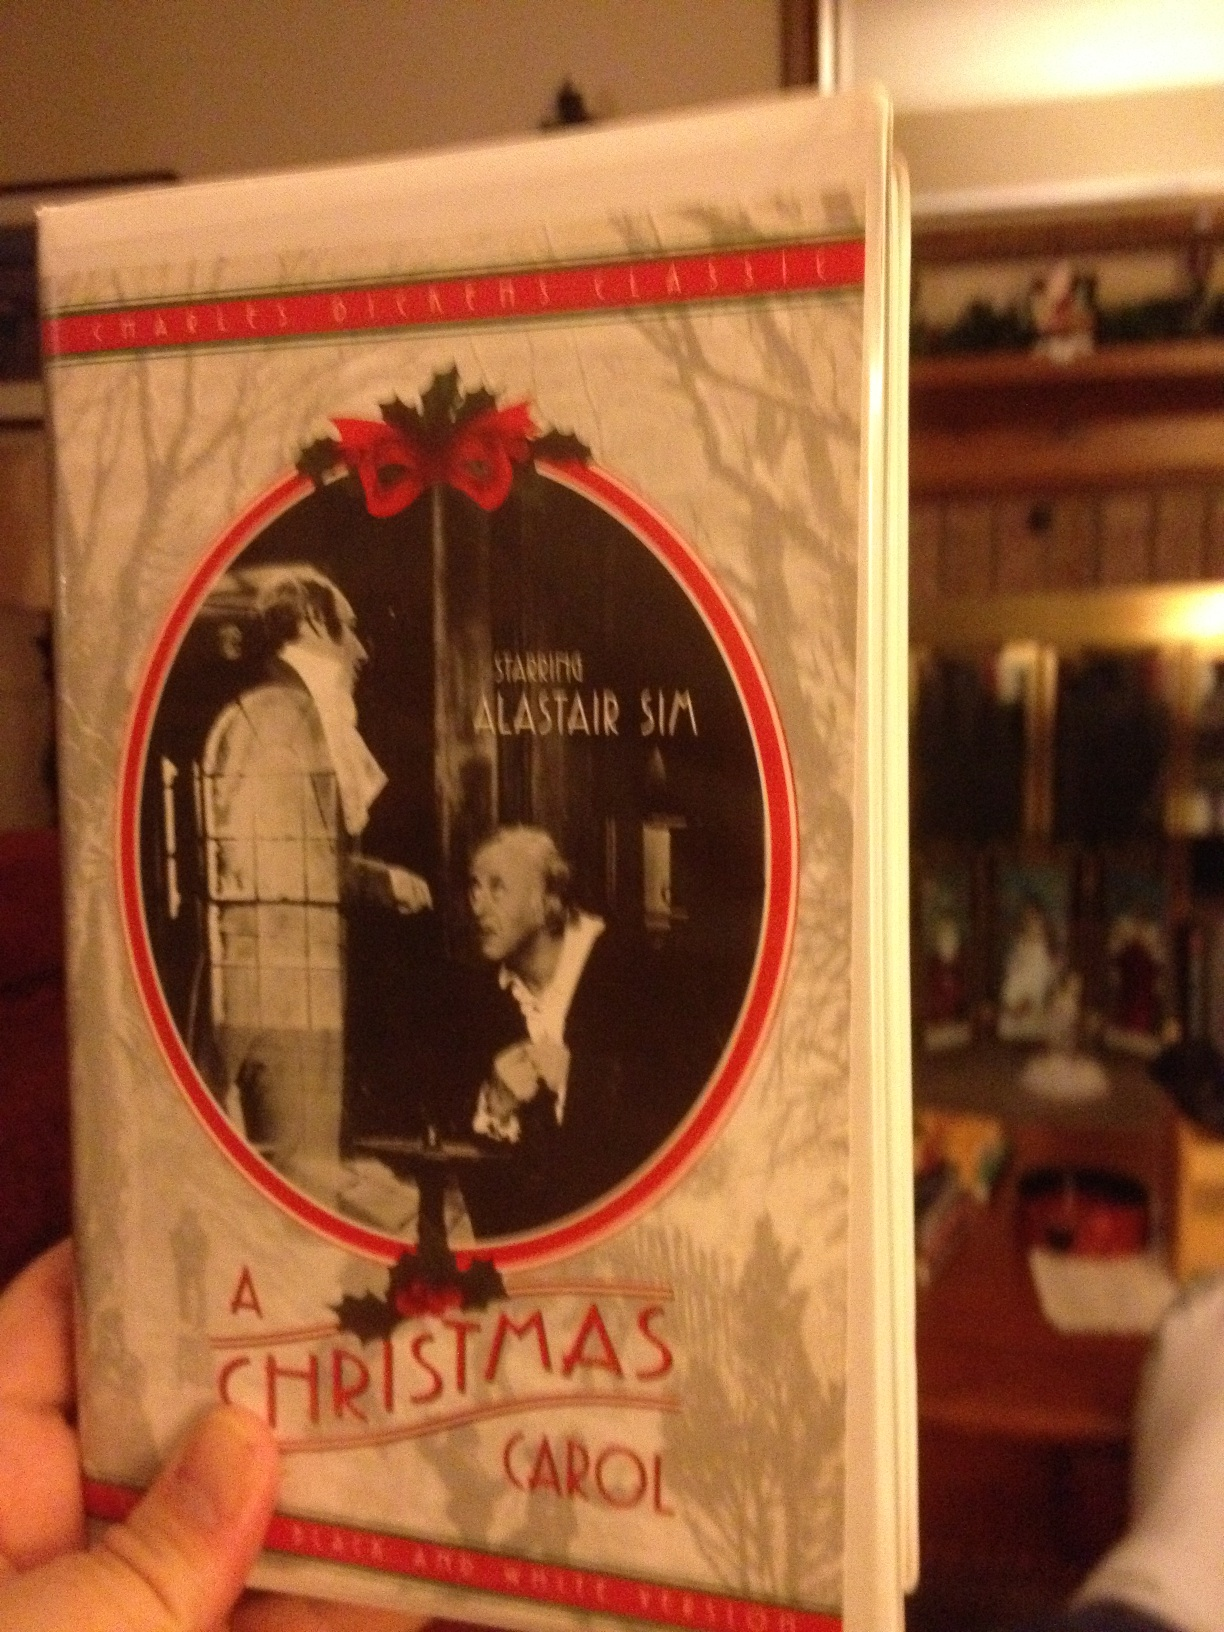What is the significance of this film? This film, 'A Christmas Carol' starring Alastair Sim, is significant because it is one of the most beloved adaptations of Charles Dickens' classic novella. It vividly brings to life the story of Ebenezer Scrooge's transformation from a miserly, selfish man to a warm-hearted benefactor. The film has been praised for its faithful representation of the original story and its ability to capture the essence of the Victorian era. 